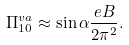Convert formula to latex. <formula><loc_0><loc_0><loc_500><loc_500>\Pi _ { 1 0 } ^ { v a } \approx \sin \alpha { \frac { e B } { 2 \pi ^ { 2 } } } .</formula> 